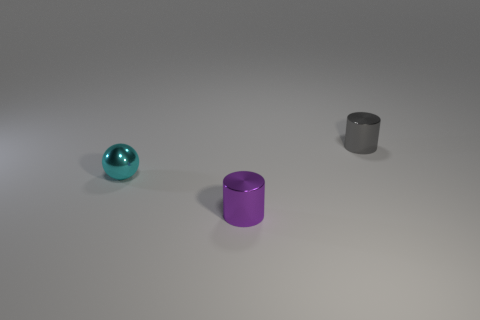There is a cyan shiny object left of the small cylinder that is in front of the gray metal thing; what shape is it? sphere 